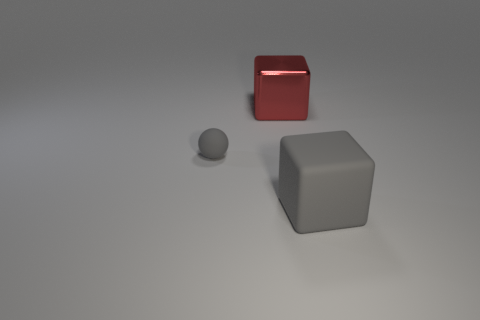Add 3 tiny things. How many objects exist? 6 Subtract all red cubes. How many cubes are left? 1 Subtract all spheres. How many objects are left? 2 Subtract all blue spheres. How many gray cubes are left? 1 Add 1 large red metallic blocks. How many large red metallic blocks are left? 2 Add 3 big yellow cylinders. How many big yellow cylinders exist? 3 Subtract 1 gray balls. How many objects are left? 2 Subtract all yellow spheres. Subtract all brown cylinders. How many spheres are left? 1 Subtract all matte spheres. Subtract all tiny gray things. How many objects are left? 1 